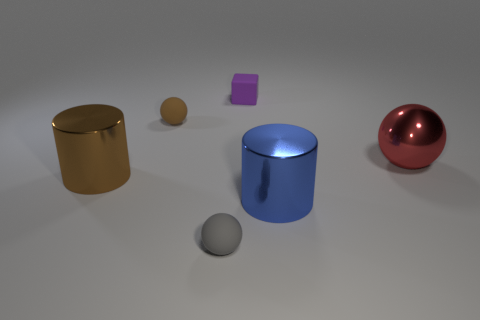There is a matte thing in front of the brown ball; is it the same shape as the large metallic thing that is in front of the large brown cylinder?
Your response must be concise. No. There is a red metal ball; are there any small objects behind it?
Keep it short and to the point. Yes. What is the color of the other big object that is the same shape as the large blue thing?
Keep it short and to the point. Brown. Is there anything else that has the same shape as the small brown object?
Ensure brevity in your answer.  Yes. There is a red object that is in front of the brown matte ball; what material is it?
Your answer should be compact. Metal. There is another metal object that is the same shape as the big brown object; what is its size?
Offer a very short reply. Large. What number of other brown spheres have the same material as the big ball?
Your answer should be very brief. 0. How many other large balls are the same color as the metal ball?
Make the answer very short. 0. How many objects are either large blue things that are in front of the large metallic ball or shiny objects behind the brown cylinder?
Ensure brevity in your answer.  2. Is the number of big shiny things that are behind the brown metallic cylinder less than the number of red metallic objects?
Your answer should be compact. No. 